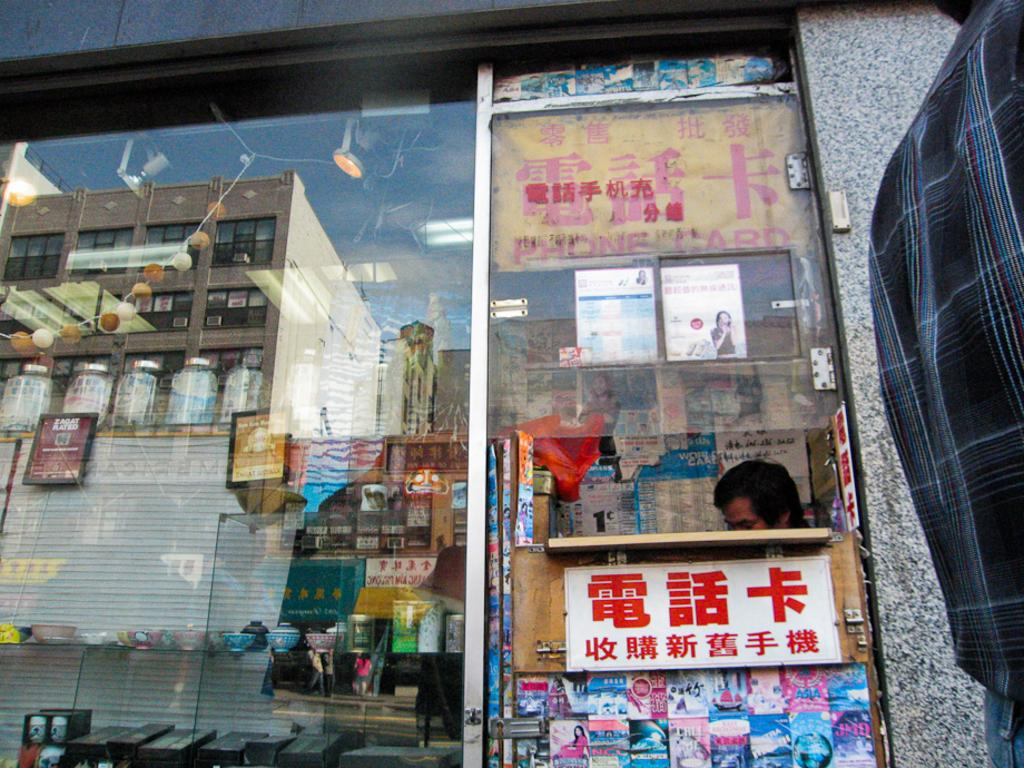<image>
Render a clear and concise summary of the photo. A comic called Call Me is displayed below a red sign in Chinese 